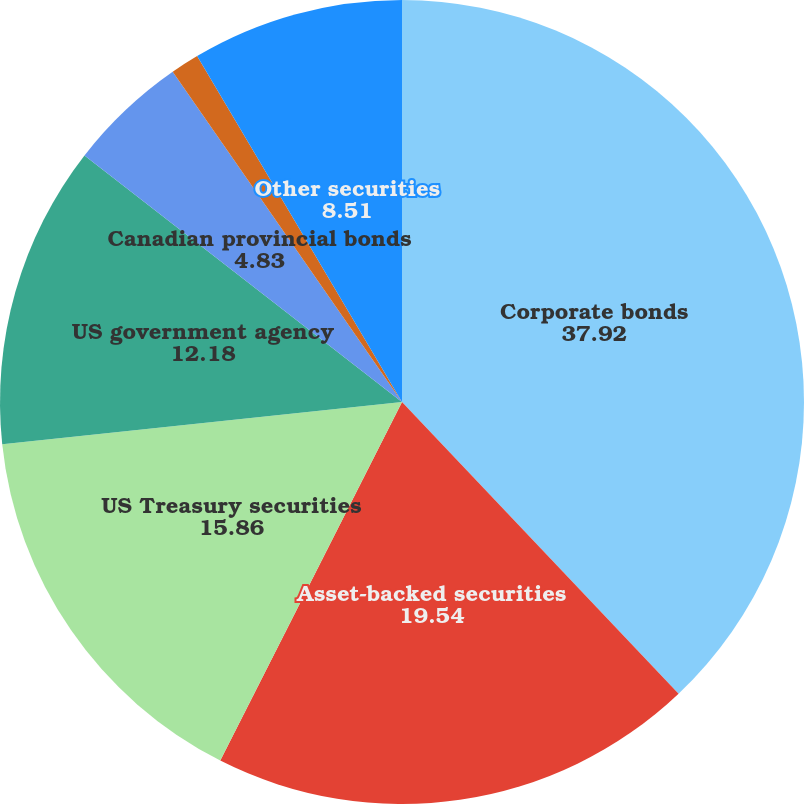Convert chart. <chart><loc_0><loc_0><loc_500><loc_500><pie_chart><fcel>Corporate bonds<fcel>Asset-backed securities<fcel>US Treasury securities<fcel>US government agency<fcel>Canadian provincial bonds<fcel>Municipal bonds<fcel>Other securities<nl><fcel>37.92%<fcel>19.54%<fcel>15.86%<fcel>12.18%<fcel>4.83%<fcel>1.15%<fcel>8.51%<nl></chart> 